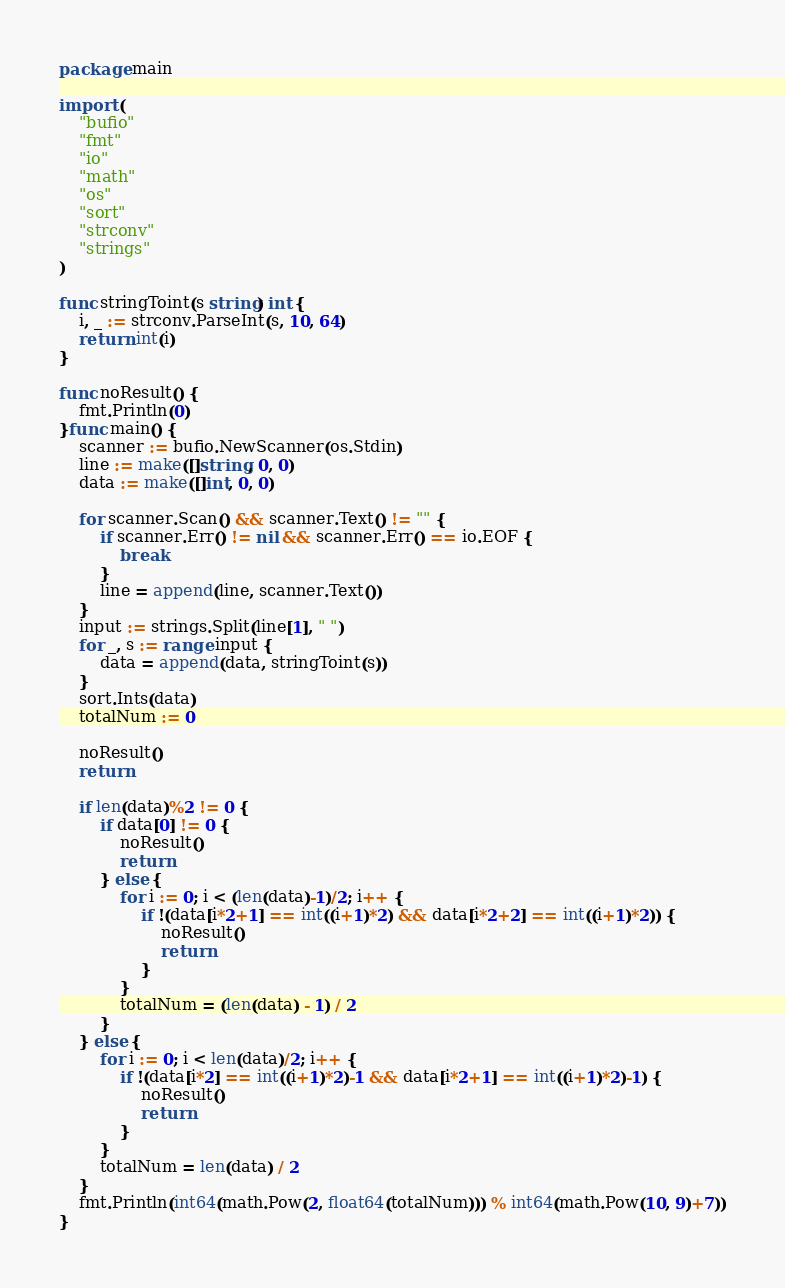<code> <loc_0><loc_0><loc_500><loc_500><_Go_>package main

import (
    "bufio"
    "fmt"
    "io"
    "math"
    "os"
    "sort"
    "strconv"
    "strings"
)

func stringToint(s string) int {
    i, _ := strconv.ParseInt(s, 10, 64)
    return int(i)
}

func noResult() {
    fmt.Println(0)
}func main() {
    scanner := bufio.NewScanner(os.Stdin)
    line := make([]string, 0, 0)
    data := make([]int, 0, 0)

    for scanner.Scan() && scanner.Text() != "" {
        if scanner.Err() != nil && scanner.Err() == io.EOF {
            break
        }
        line = append(line, scanner.Text())
    }
    input := strings.Split(line[1], " ")
    for _, s := range input {
        data = append(data, stringToint(s))
    }
    sort.Ints(data)
    totalNum := 0

    noResult()
    return

    if len(data)%2 != 0 {
        if data[0] != 0 {
            noResult()
            return
        } else {
            for i := 0; i < (len(data)-1)/2; i++ {
                if !(data[i*2+1] == int((i+1)*2) && data[i*2+2] == int((i+1)*2)) {
                    noResult()
                    return
                }
            }
            totalNum = (len(data) - 1) / 2
        }
    } else {
        for i := 0; i < len(data)/2; i++ {
            if !(data[i*2] == int((i+1)*2)-1 && data[i*2+1] == int((i+1)*2)-1) {
                noResult()
                return
            }
        }
        totalNum = len(data) / 2
    }
    fmt.Println(int64(math.Pow(2, float64(totalNum))) % int64(math.Pow(10, 9)+7))
}

</code> 